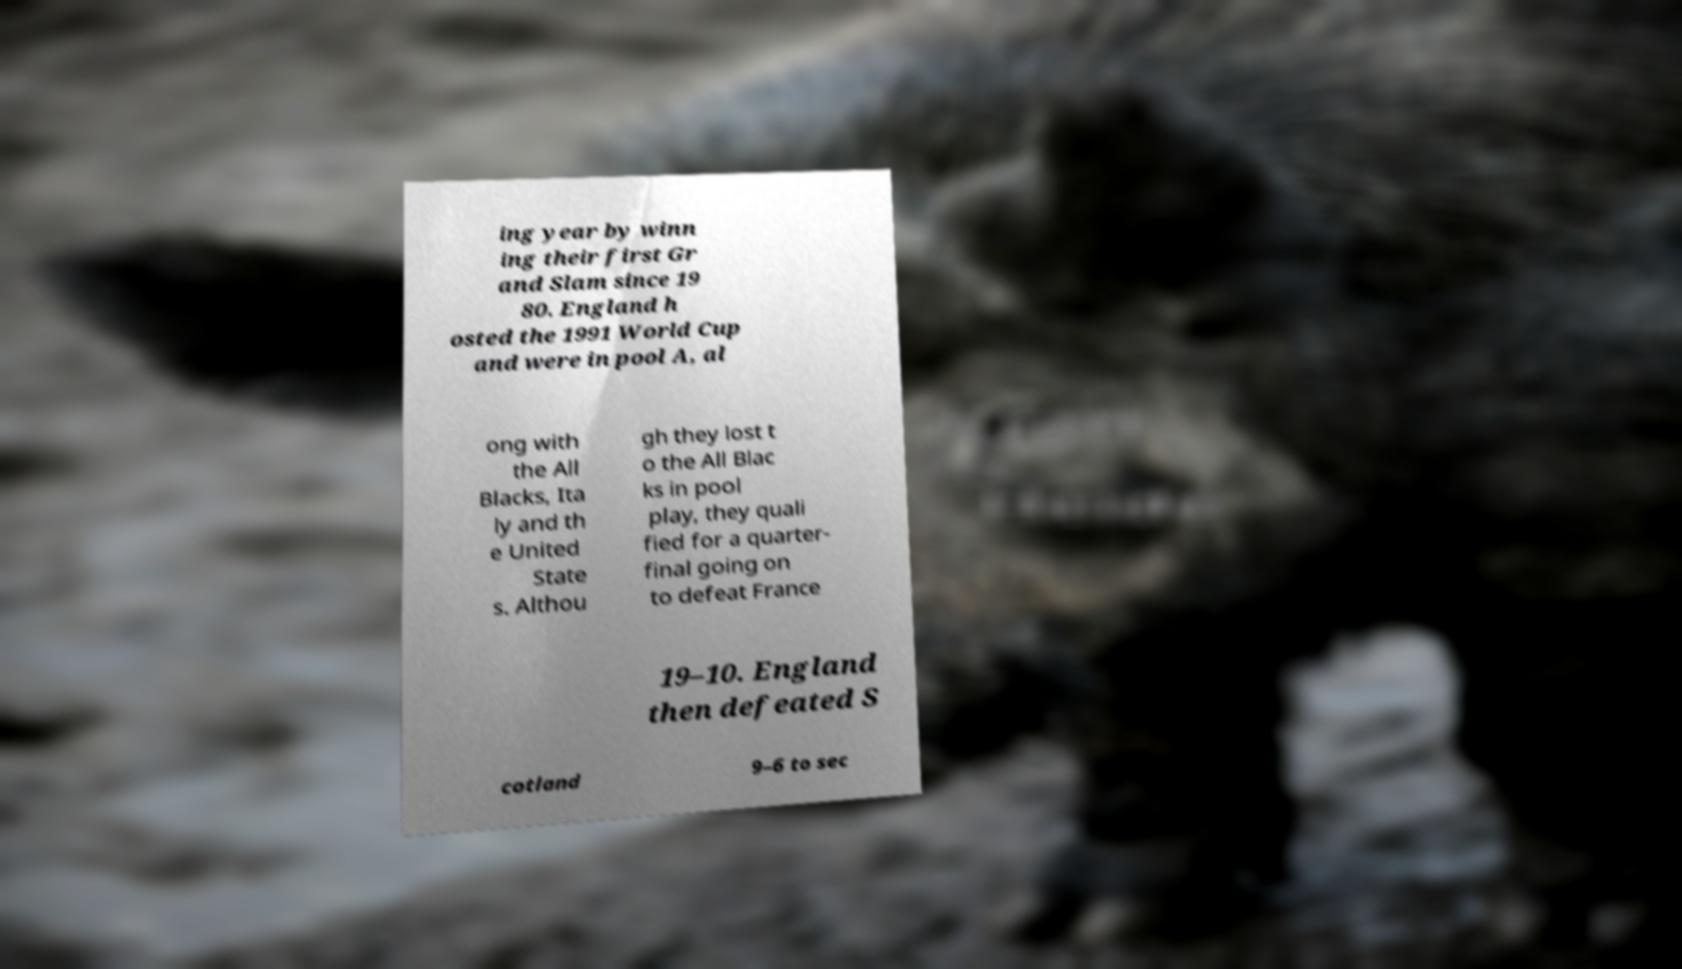Please identify and transcribe the text found in this image. ing year by winn ing their first Gr and Slam since 19 80. England h osted the 1991 World Cup and were in pool A, al ong with the All Blacks, Ita ly and th e United State s. Althou gh they lost t o the All Blac ks in pool play, they quali fied for a quarter- final going on to defeat France 19–10. England then defeated S cotland 9–6 to sec 